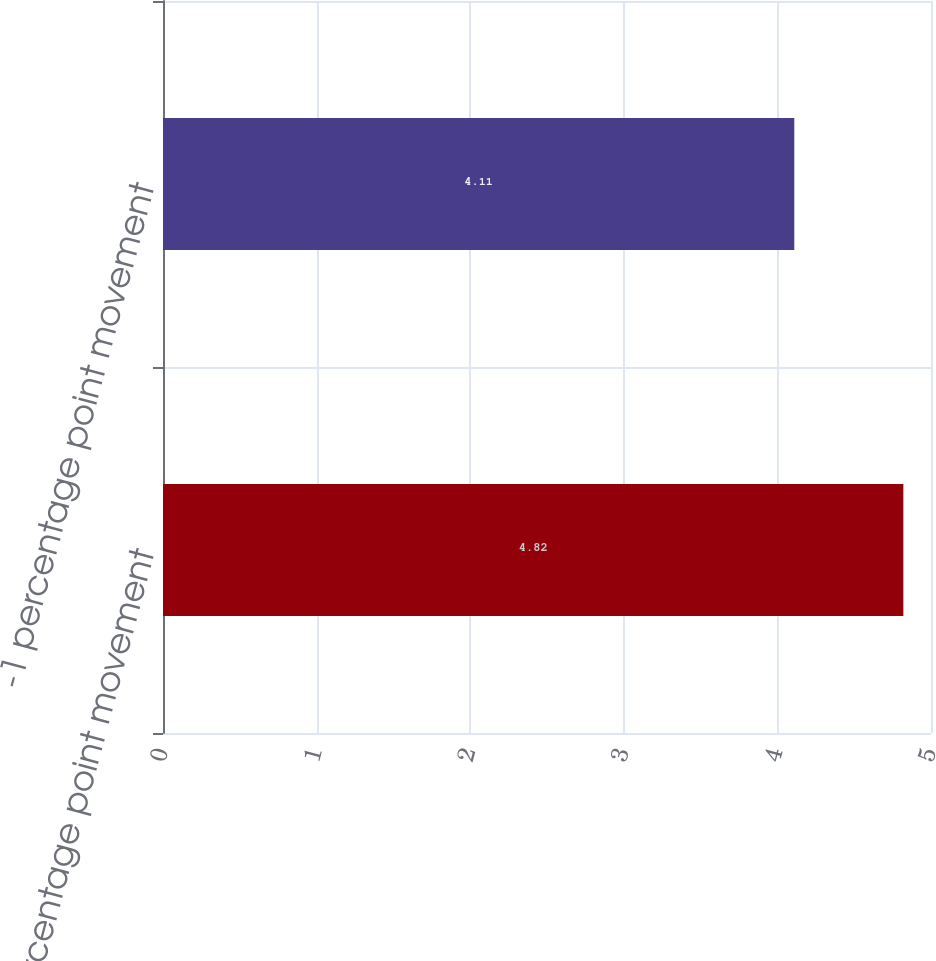Convert chart. <chart><loc_0><loc_0><loc_500><loc_500><bar_chart><fcel>+1 percentage point movement<fcel>-1 percentage point movement<nl><fcel>4.82<fcel>4.11<nl></chart> 